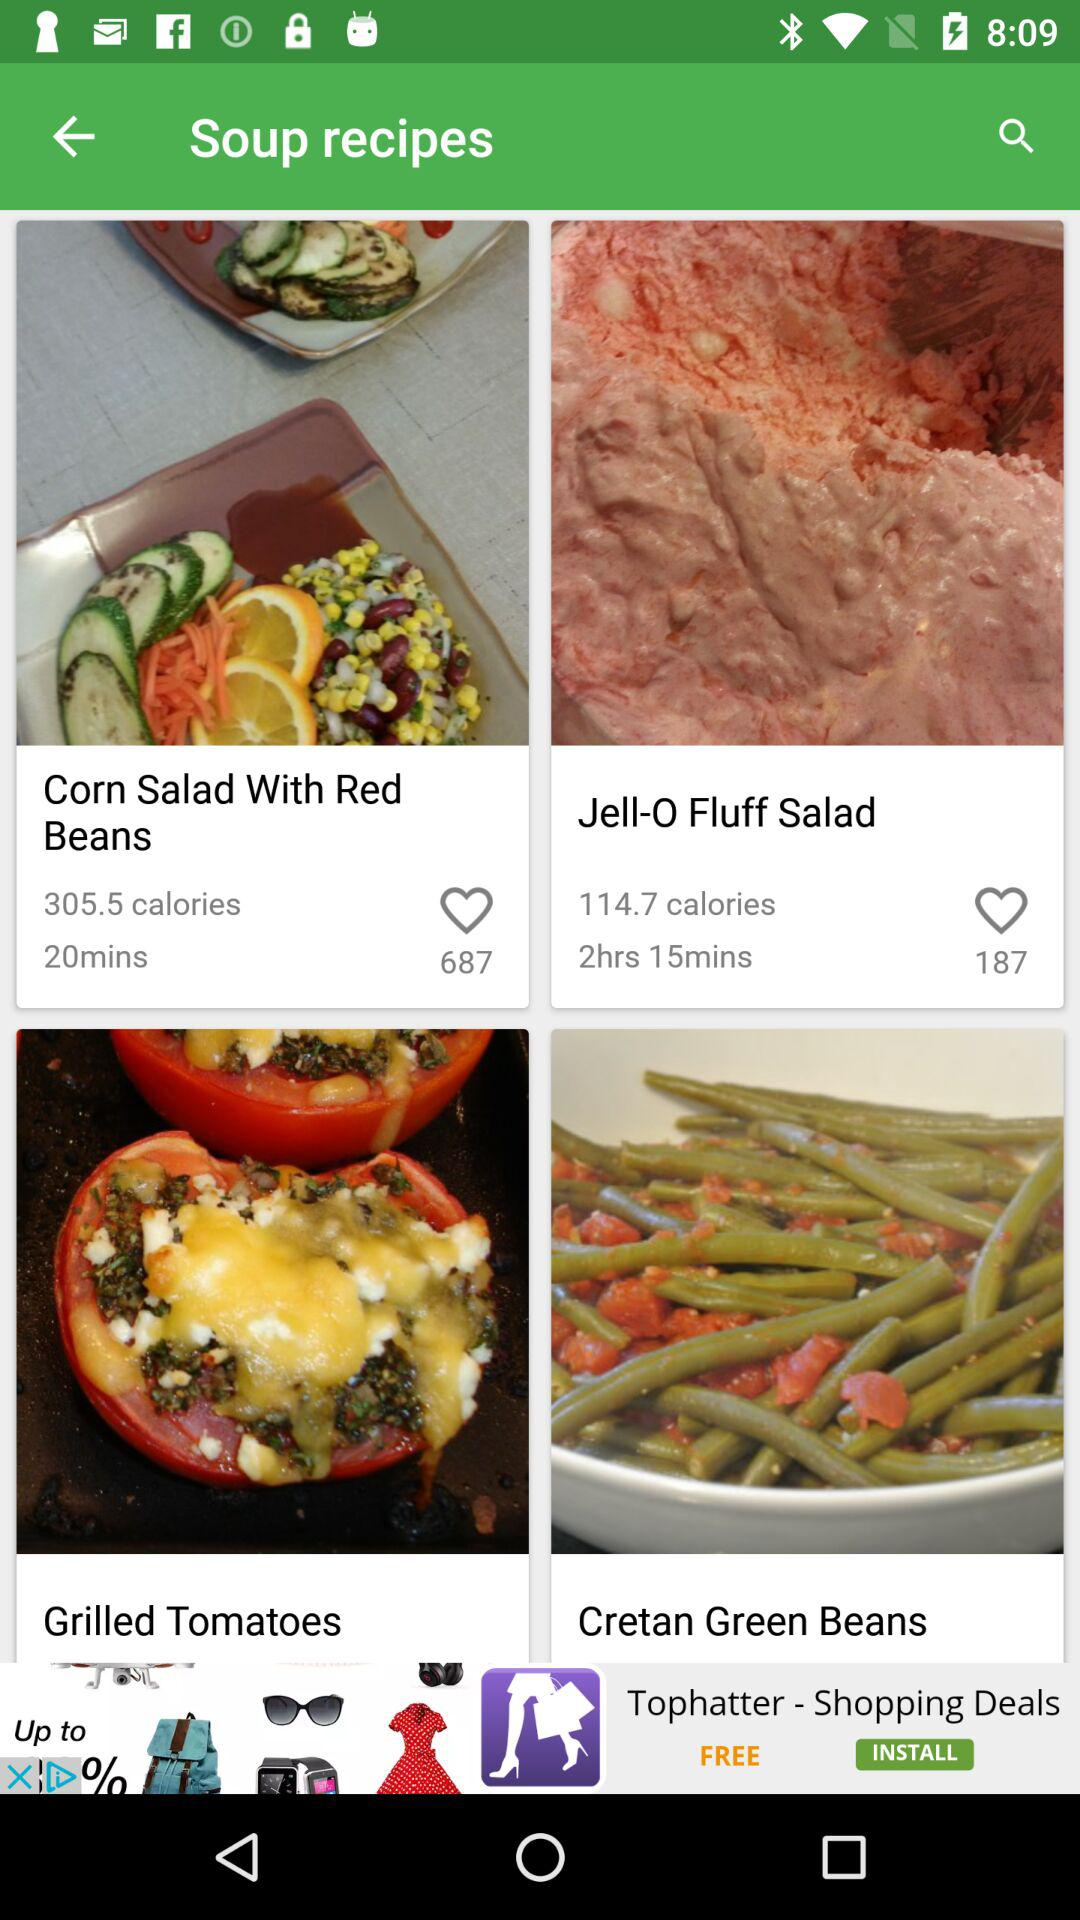How many likes are received for "Corn Salad With Red Beans"? The number of likes received for "Corn Salad With Red Beans" is 687. 